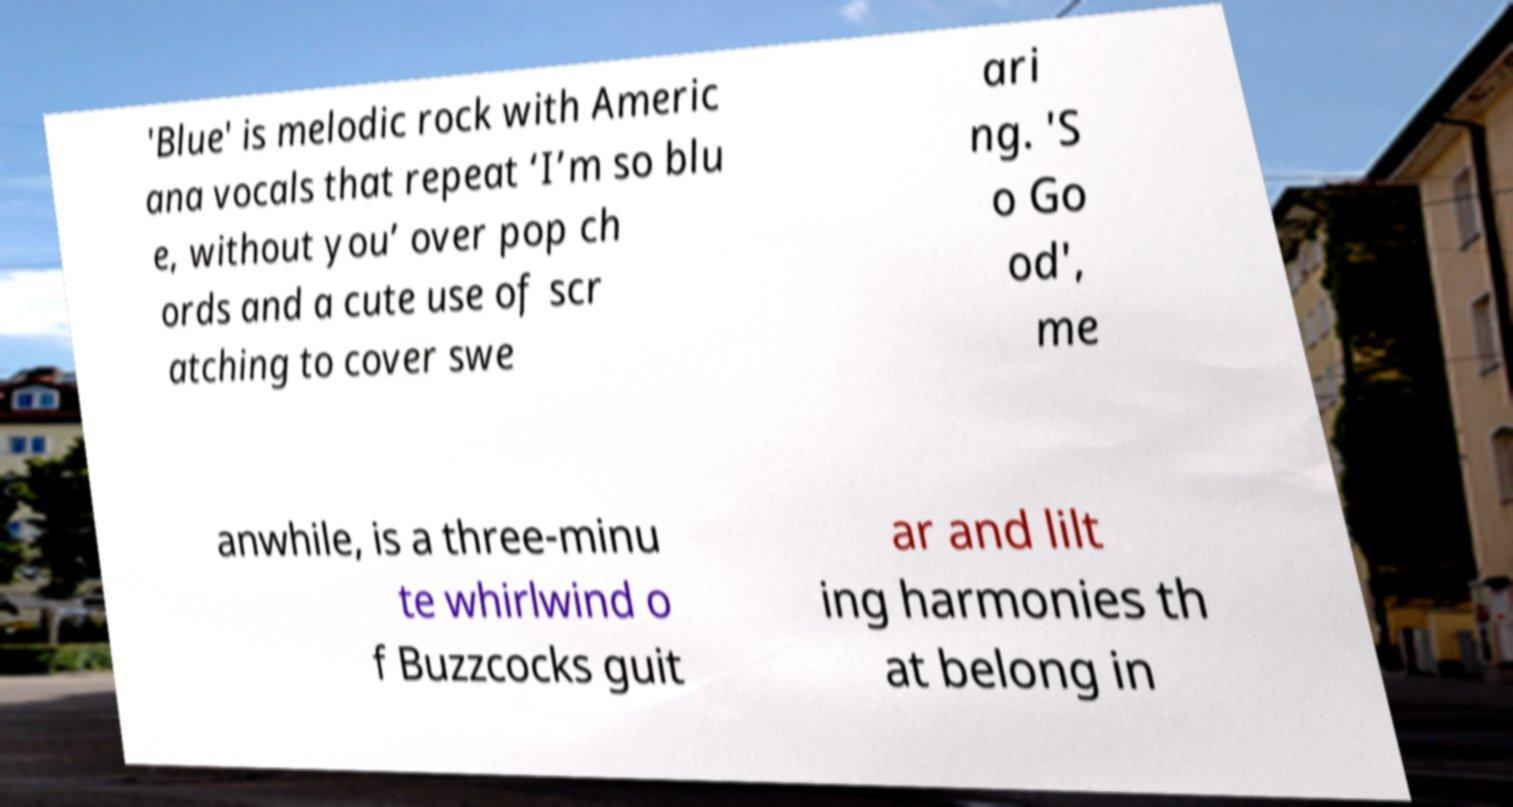I need the written content from this picture converted into text. Can you do that? 'Blue' is melodic rock with Americ ana vocals that repeat ‘I’m so blu e, without you’ over pop ch ords and a cute use of scr atching to cover swe ari ng. 'S o Go od', me anwhile, is a three-minu te whirlwind o f Buzzcocks guit ar and lilt ing harmonies th at belong in 